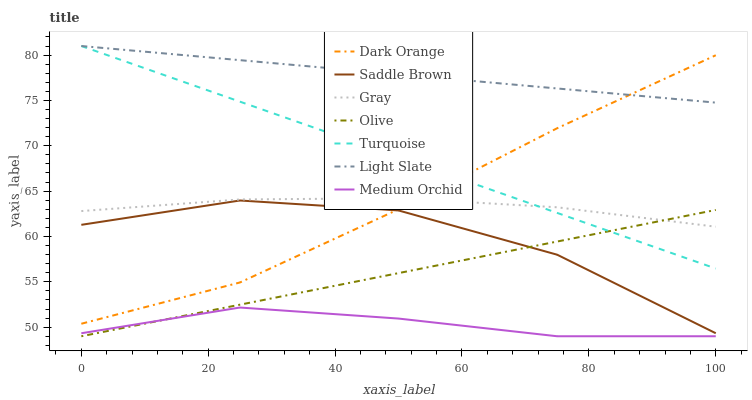Does Medium Orchid have the minimum area under the curve?
Answer yes or no. Yes. Does Light Slate have the maximum area under the curve?
Answer yes or no. Yes. Does Turquoise have the minimum area under the curve?
Answer yes or no. No. Does Turquoise have the maximum area under the curve?
Answer yes or no. No. Is Turquoise the smoothest?
Answer yes or no. Yes. Is Saddle Brown the roughest?
Answer yes or no. Yes. Is Gray the smoothest?
Answer yes or no. No. Is Gray the roughest?
Answer yes or no. No. Does Medium Orchid have the lowest value?
Answer yes or no. Yes. Does Turquoise have the lowest value?
Answer yes or no. No. Does Light Slate have the highest value?
Answer yes or no. Yes. Does Gray have the highest value?
Answer yes or no. No. Is Olive less than Light Slate?
Answer yes or no. Yes. Is Saddle Brown greater than Medium Orchid?
Answer yes or no. Yes. Does Dark Orange intersect Saddle Brown?
Answer yes or no. Yes. Is Dark Orange less than Saddle Brown?
Answer yes or no. No. Is Dark Orange greater than Saddle Brown?
Answer yes or no. No. Does Olive intersect Light Slate?
Answer yes or no. No. 